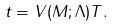Convert formula to latex. <formula><loc_0><loc_0><loc_500><loc_500>t = V ( M ; \Lambda ) T .</formula> 